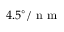Convert formula to latex. <formula><loc_0><loc_0><loc_500><loc_500>4 . 5 ^ { \circ } / n m</formula> 